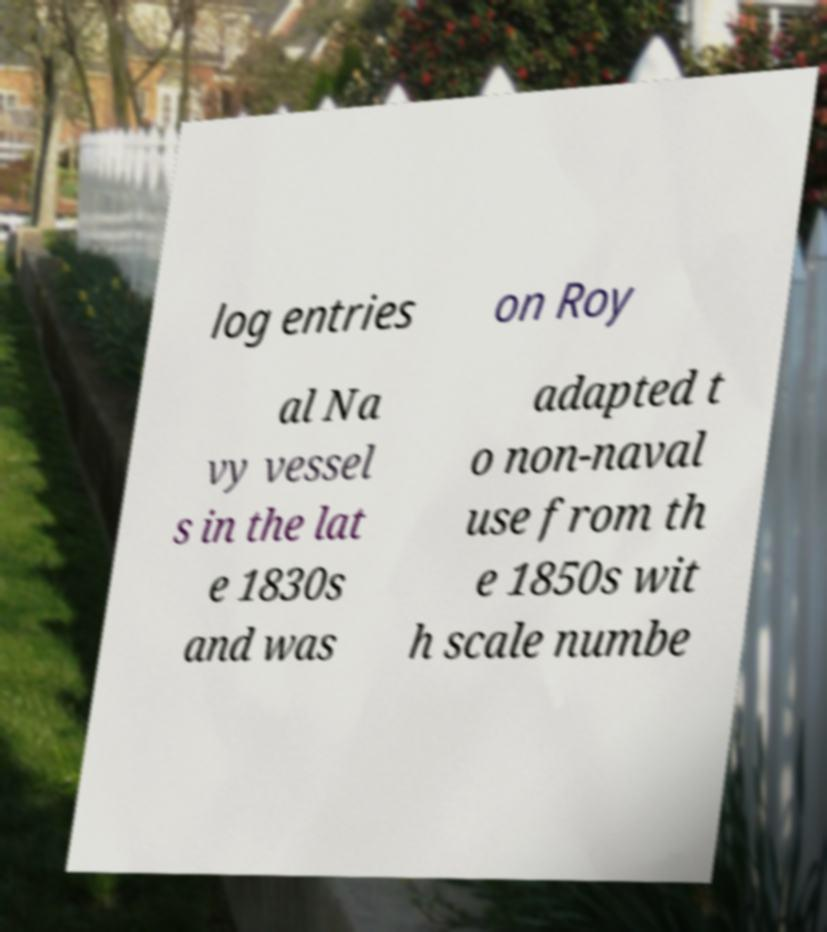Could you extract and type out the text from this image? log entries on Roy al Na vy vessel s in the lat e 1830s and was adapted t o non-naval use from th e 1850s wit h scale numbe 